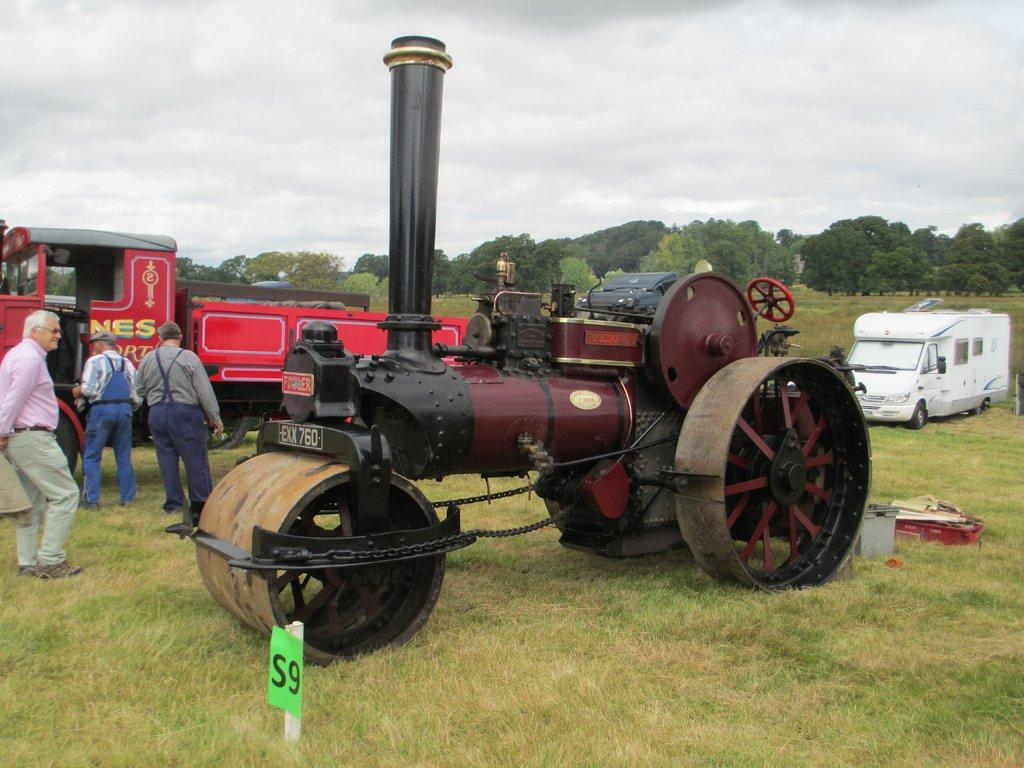What type of vehicles can be seen in the image? There are vehicles on a grassland in the image. How many people are present in the image? There are three people standing in the image. What can be seen in the background of the image? There are trees and the sky visible in the background of the image. What type of grip do the trees have in the image? The image does not show the trees' grip; it only shows their appearance in the background. What color is the underwear of the people in the image? The image does not show the people's underwear, so it cannot be determined from the image. 